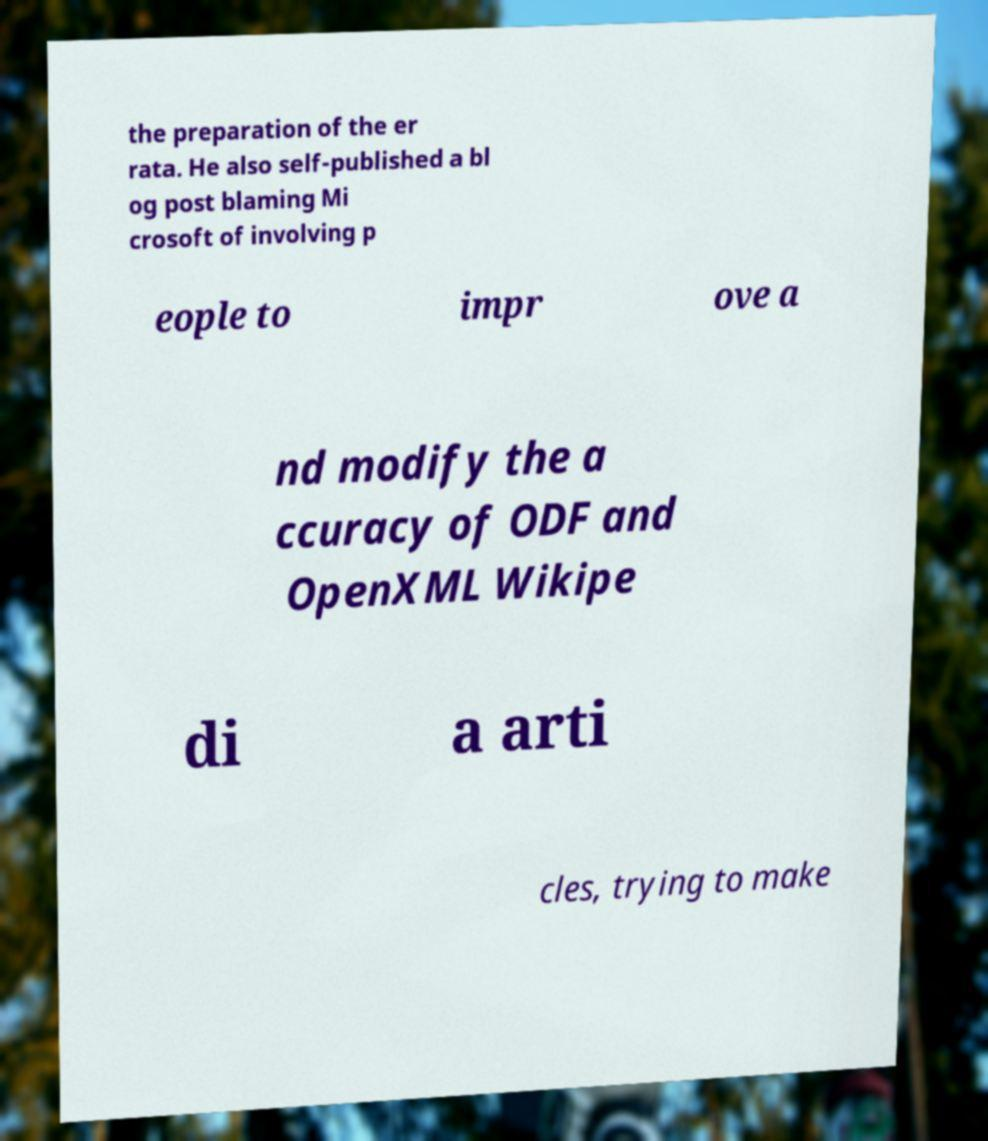I need the written content from this picture converted into text. Can you do that? the preparation of the er rata. He also self-published a bl og post blaming Mi crosoft of involving p eople to impr ove a nd modify the a ccuracy of ODF and OpenXML Wikipe di a arti cles, trying to make 